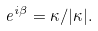Convert formula to latex. <formula><loc_0><loc_0><loc_500><loc_500>e ^ { i \beta } = \kappa / | \kappa | .</formula> 